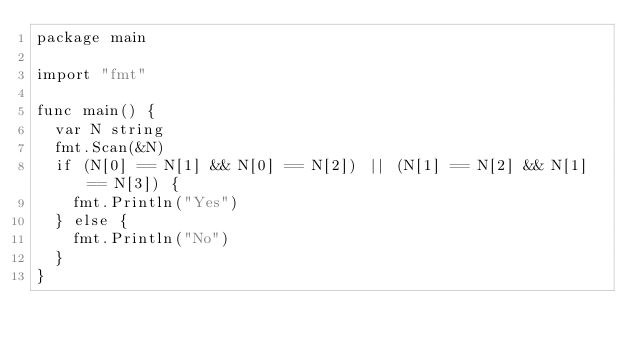<code> <loc_0><loc_0><loc_500><loc_500><_Go_>package main

import "fmt"

func main() {
	var N string
	fmt.Scan(&N)
	if (N[0] == N[1] && N[0] == N[2]) || (N[1] == N[2] && N[1] == N[3]) {
		fmt.Println("Yes")
	} else {
		fmt.Println("No")
	}
}
</code> 